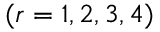<formula> <loc_0><loc_0><loc_500><loc_500>( r = 1 , 2 , 3 , 4 )</formula> 